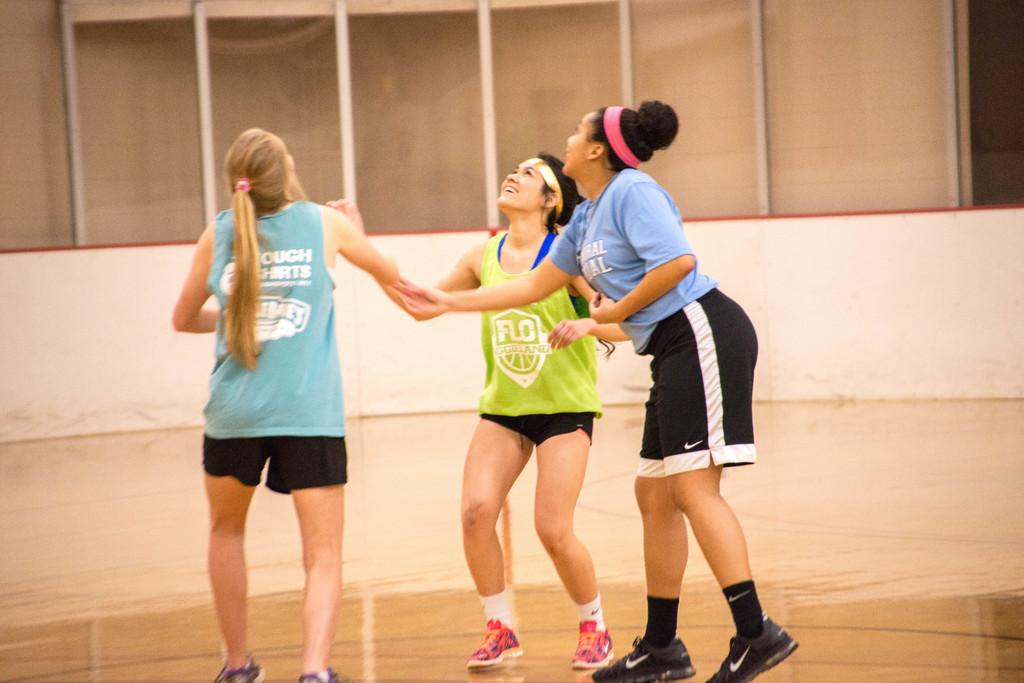How many people are in the image? There are three women in the image. What are the women doing in the image? The women are standing on the floor. What can be seen in the background of the image? There is a wall and glass windows in the background of the image. What type of fuel is being used by the rat in the image? There is no rat present in the image, so it is not possible to determine what type of fuel it might be using. 